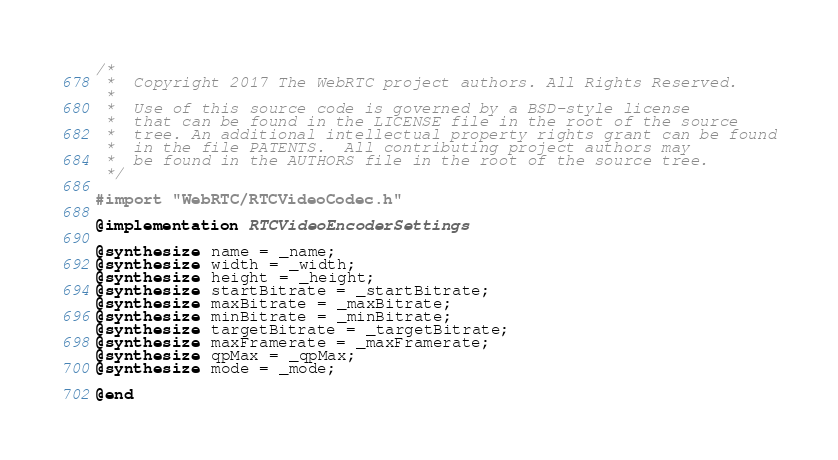<code> <loc_0><loc_0><loc_500><loc_500><_ObjectiveC_>/*
 *  Copyright 2017 The WebRTC project authors. All Rights Reserved.
 *
 *  Use of this source code is governed by a BSD-style license
 *  that can be found in the LICENSE file in the root of the source
 *  tree. An additional intellectual property rights grant can be found
 *  in the file PATENTS.  All contributing project authors may
 *  be found in the AUTHORS file in the root of the source tree.
 */

#import "WebRTC/RTCVideoCodec.h"

@implementation RTCVideoEncoderSettings

@synthesize name = _name;
@synthesize width = _width;
@synthesize height = _height;
@synthesize startBitrate = _startBitrate;
@synthesize maxBitrate = _maxBitrate;
@synthesize minBitrate = _minBitrate;
@synthesize targetBitrate = _targetBitrate;
@synthesize maxFramerate = _maxFramerate;
@synthesize qpMax = _qpMax;
@synthesize mode = _mode;

@end
</code> 